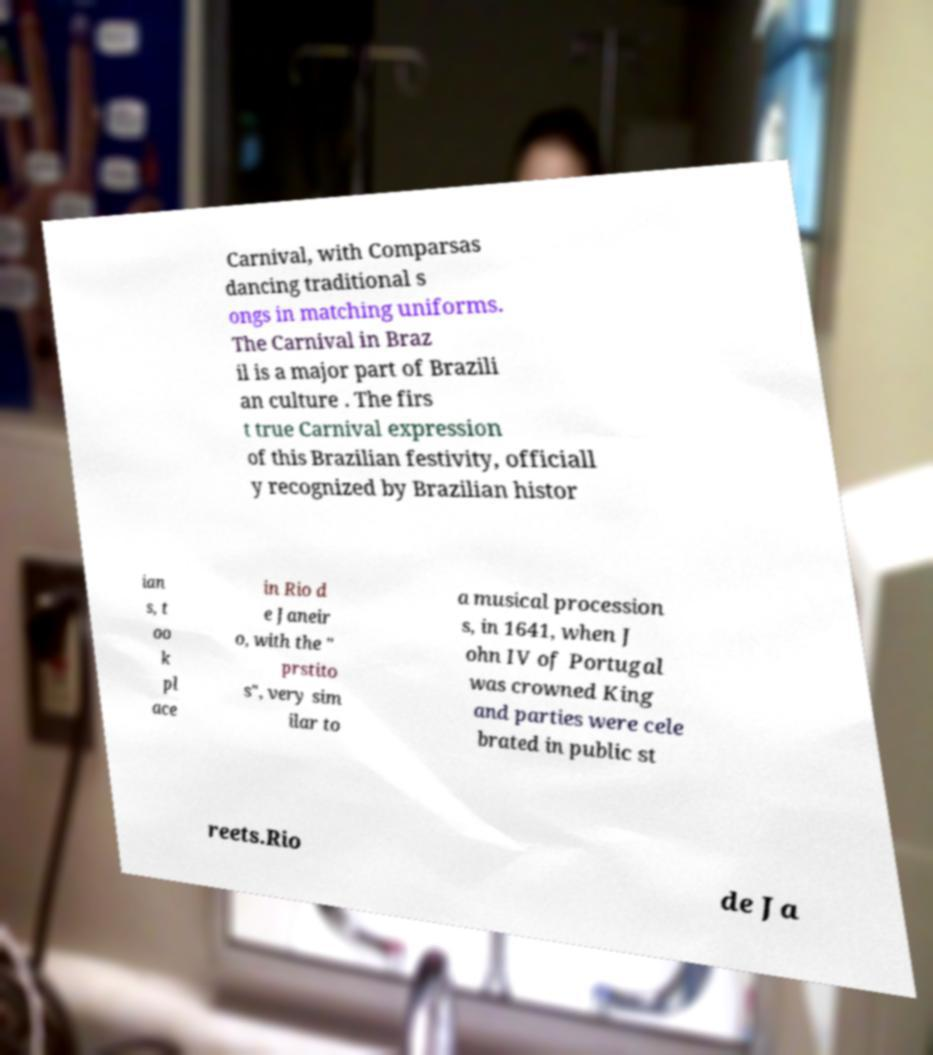For documentation purposes, I need the text within this image transcribed. Could you provide that? Carnival, with Comparsas dancing traditional s ongs in matching uniforms. The Carnival in Braz il is a major part of Brazili an culture . The firs t true Carnival expression of this Brazilian festivity, officiall y recognized by Brazilian histor ian s, t oo k pl ace in Rio d e Janeir o, with the " prstito s", very sim ilar to a musical procession s, in 1641, when J ohn IV of Portugal was crowned King and parties were cele brated in public st reets.Rio de Ja 